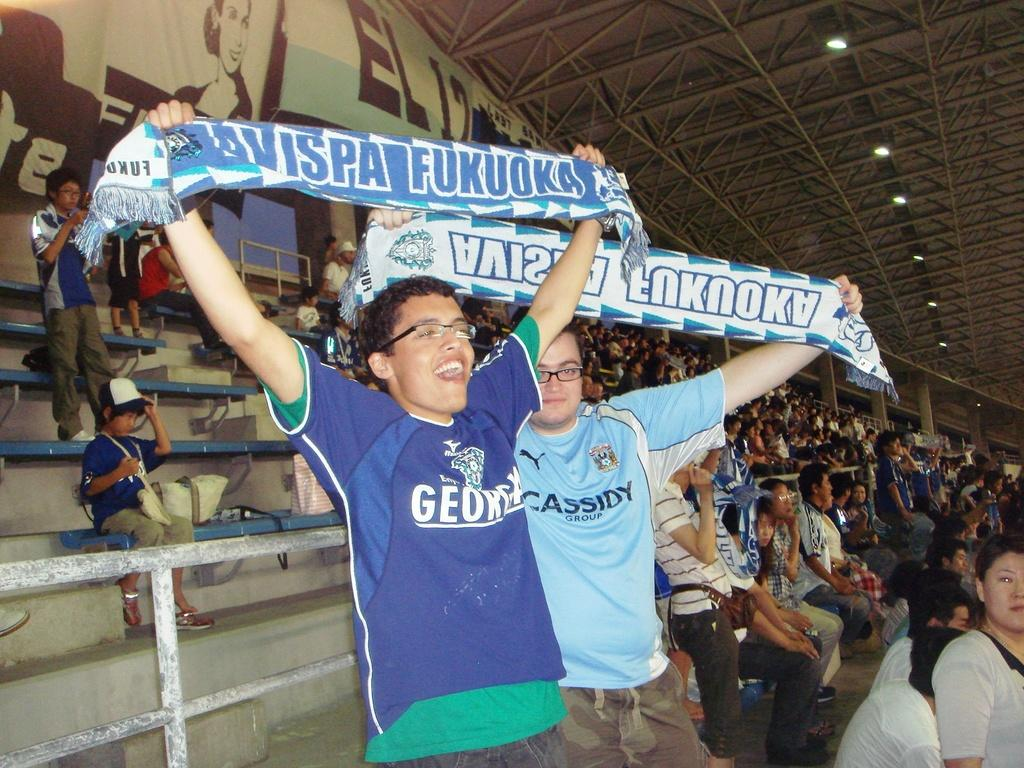What are the two persons in the image doing? The two persons in the image are standing and holding clothes. Can you describe the gathering of people in the image? There is a group of people standing and sitting on benches in the image. What can be seen in the image that provides illumination? There are lights in the image. What type of structural elements are present in the image? There are iron rods in the image. What type of signage is visible in the image? There are banners in the image. What type of lunch is being served on the floor in the image? There is no lunch or floor present in the image; it features people holding clothes and a group of people on benches. 